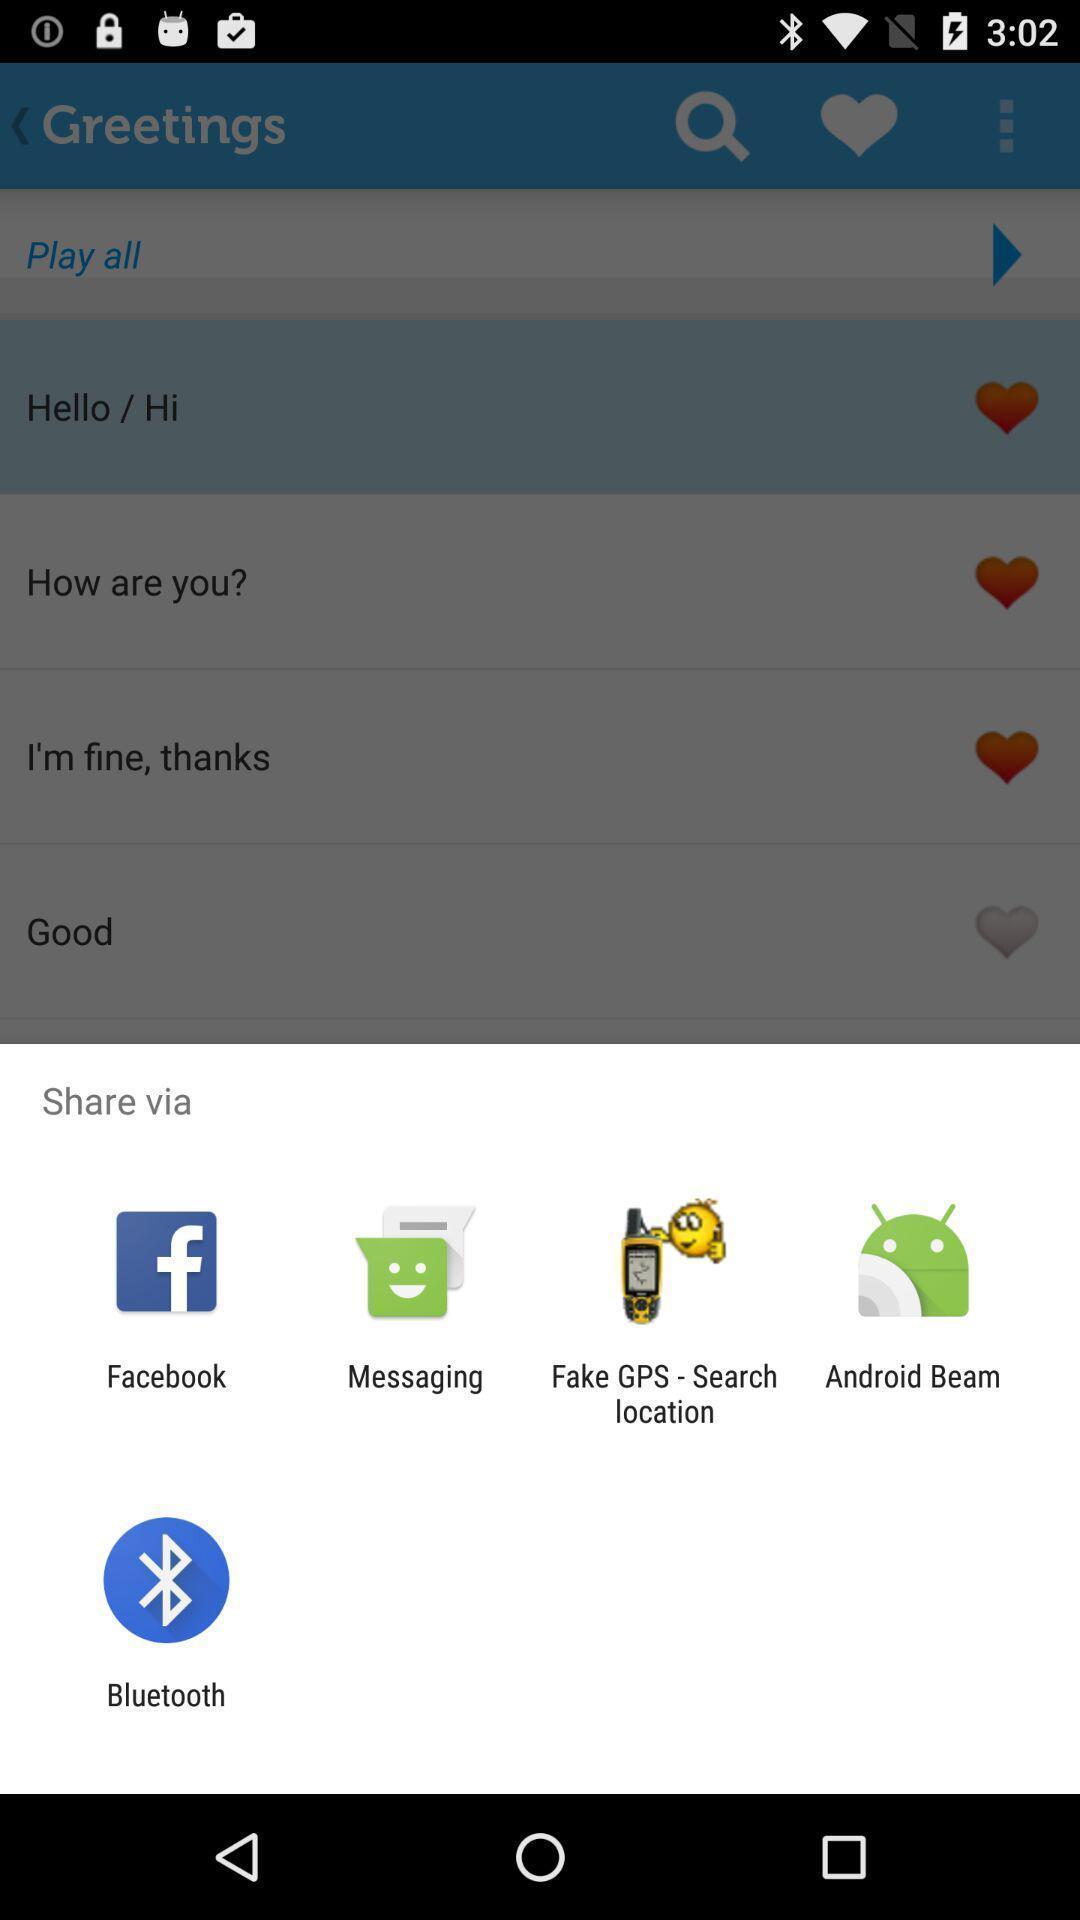Provide a detailed account of this screenshot. Pop-up showing different sharing options. 